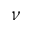Convert formula to latex. <formula><loc_0><loc_0><loc_500><loc_500>\nu</formula> 